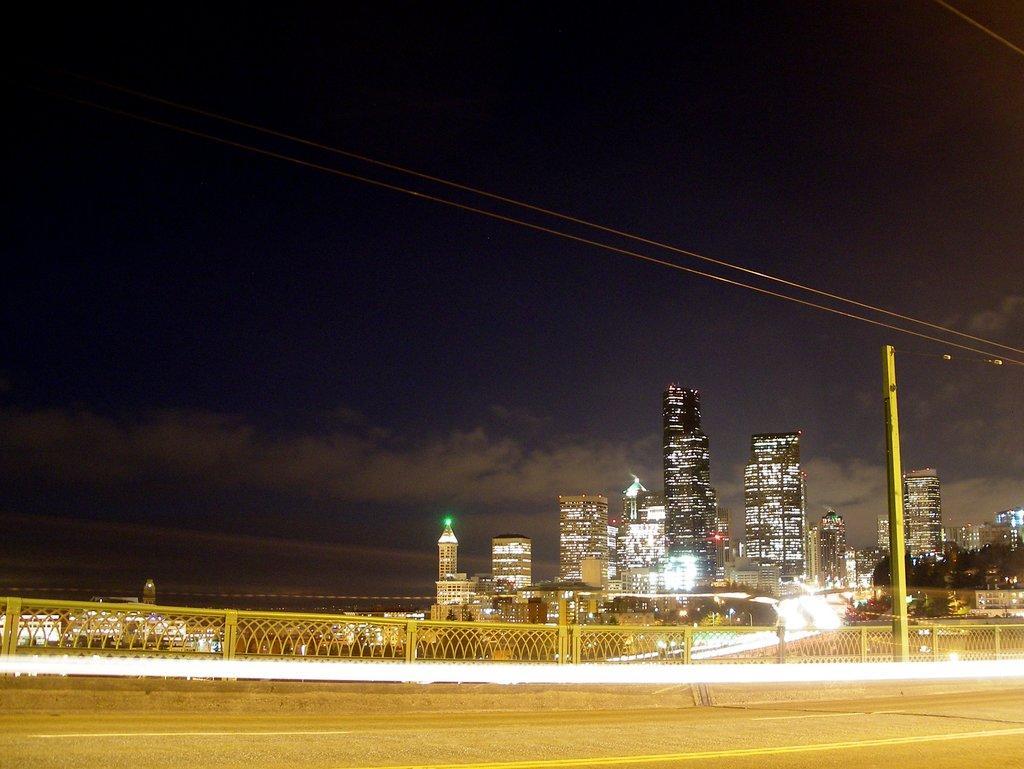Describe this image in one or two sentences. In the foreground of this image, there is a road, railing and a pole. In the background, there are buildings, skyscrapers, dark sky and the cloud. 